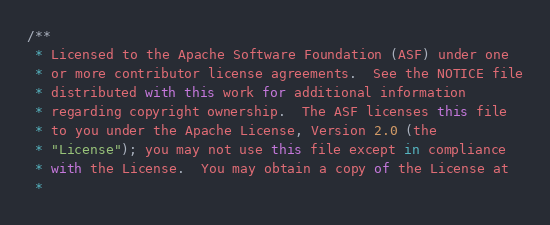Convert code to text. <code><loc_0><loc_0><loc_500><loc_500><_JavaScript_>/**
 * Licensed to the Apache Software Foundation (ASF) under one
 * or more contributor license agreements.  See the NOTICE file
 * distributed with this work for additional information
 * regarding copyright ownership.  The ASF licenses this file
 * to you under the Apache License, Version 2.0 (the
 * "License"); you may not use this file except in compliance
 * with the License.  You may obtain a copy of the License at
 *</code> 